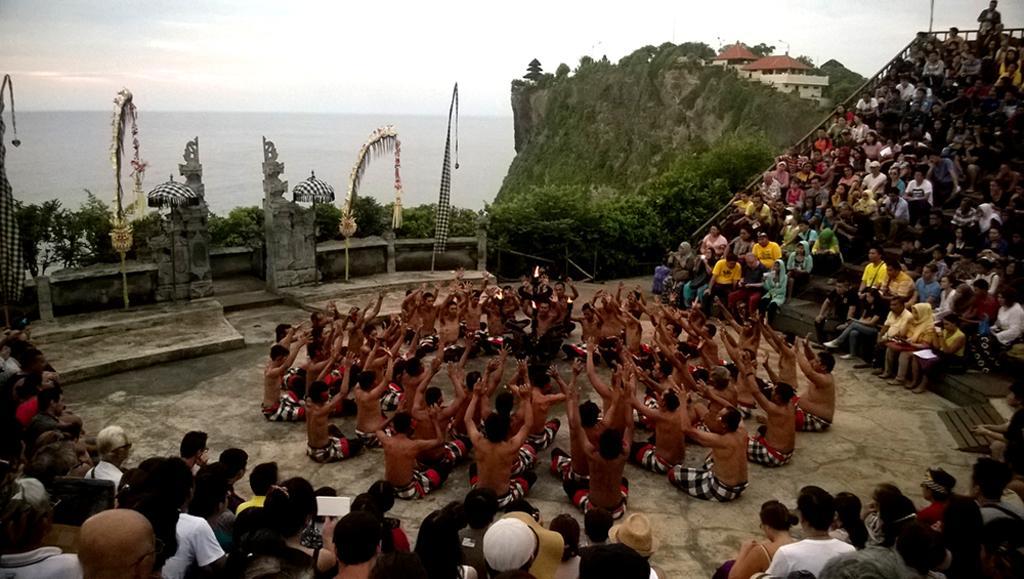Could you give a brief overview of what you see in this image? In the foreground of this image, there are persons sitting. In the middle, there are persons sitting around the man. In the background, there are houses on a cliff, trees, umbrellas and few more objects. At the top, there is the sky, cloud and we can also see the water behind the cliff. 